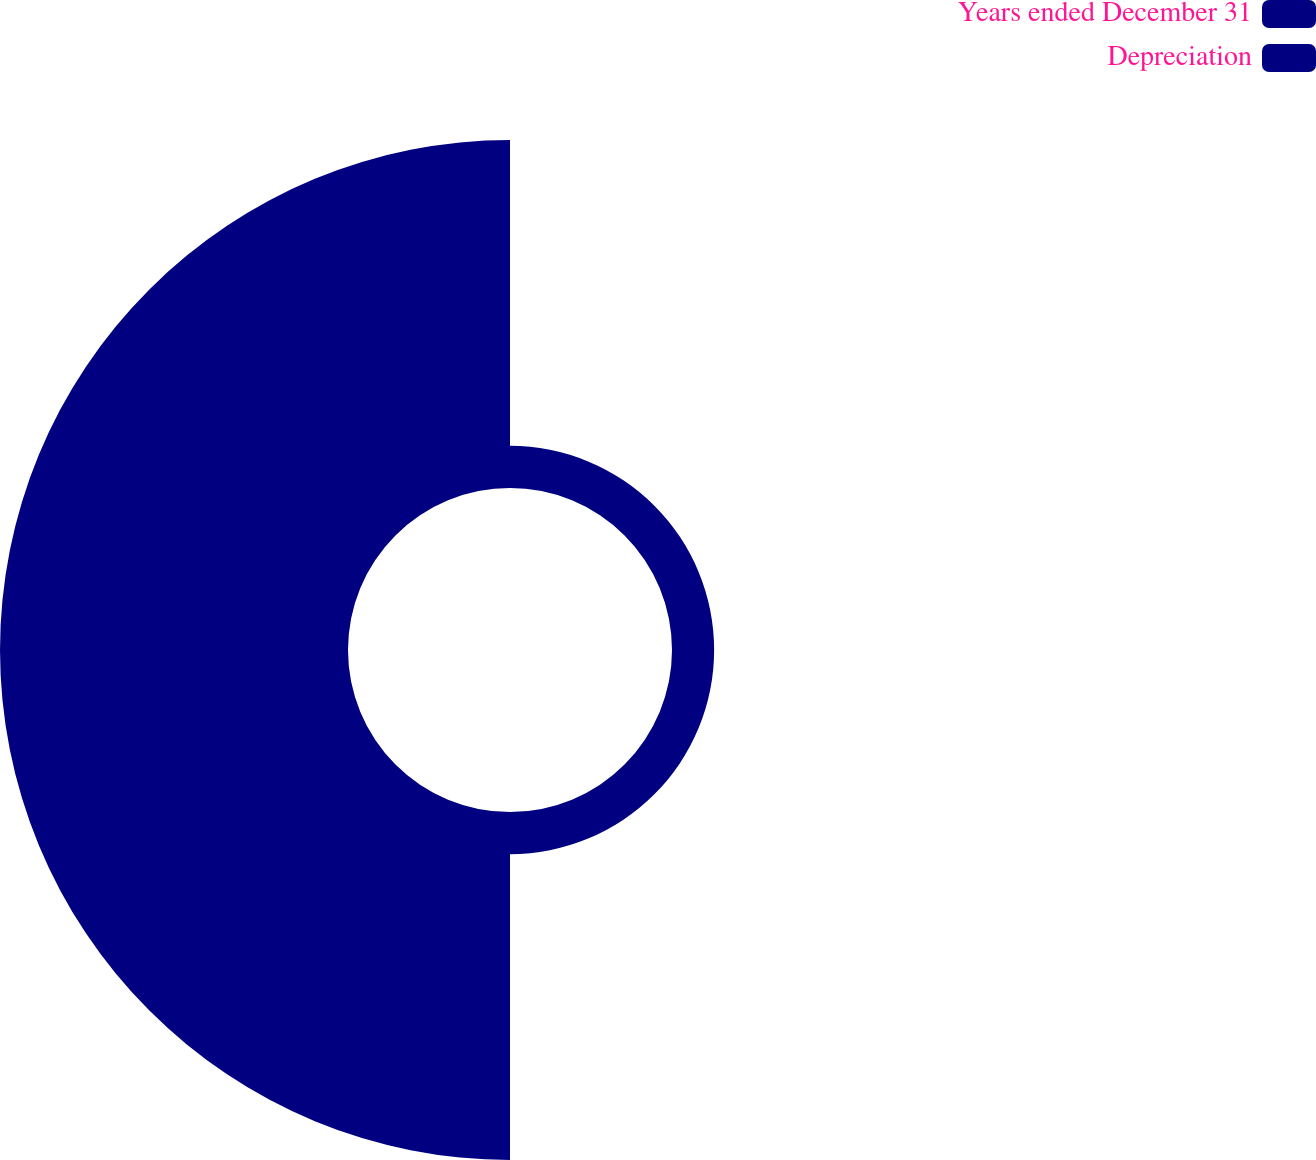Convert chart to OTSL. <chart><loc_0><loc_0><loc_500><loc_500><pie_chart><fcel>Years ended December 31<fcel>Depreciation<nl><fcel>10.8%<fcel>89.2%<nl></chart> 